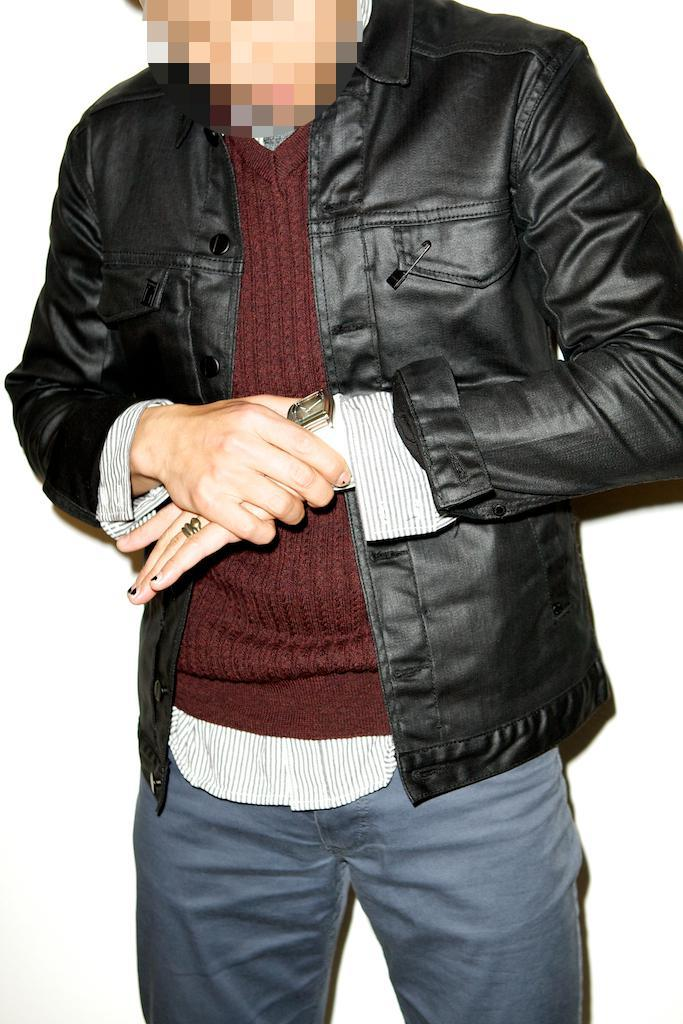What is the main subject of the image? There is a man standing in the center of the image. What is the man wearing in the image? The man is wearing a jacket in the image. Can you describe the man's face in the image? The man's face is blurry in the image. What brand of toothpaste is the man using in the image? There is no toothpaste present in the image, and therefore no brand can be identified. What type of haircut does the man have in the image? The man's hair is not visible in the image due to the blurry face, so it is impossible to determine the type of haircut. 